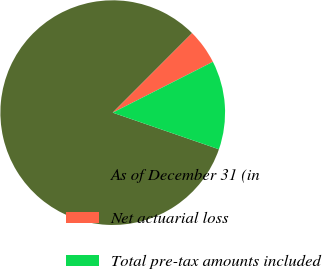Convert chart to OTSL. <chart><loc_0><loc_0><loc_500><loc_500><pie_chart><fcel>As of December 31 (in<fcel>Net actuarial loss<fcel>Total pre-tax amounts included<nl><fcel>82.2%<fcel>5.04%<fcel>12.76%<nl></chart> 